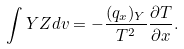<formula> <loc_0><loc_0><loc_500><loc_500>\int Y Z d v = - \frac { ( q _ { x } ) _ { Y } } { T ^ { 2 } } \frac { \partial T } { \partial x } .</formula> 